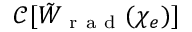Convert formula to latex. <formula><loc_0><loc_0><loc_500><loc_500>\mathcal { C } [ \tilde { W } _ { r a d } ( \chi _ { e } ) ]</formula> 